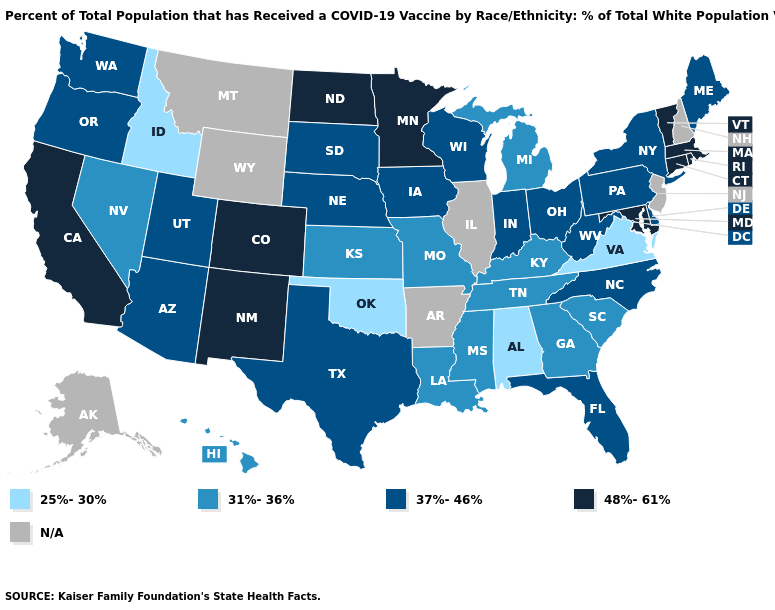What is the value of Minnesota?
Quick response, please. 48%-61%. Is the legend a continuous bar?
Answer briefly. No. Does Arizona have the highest value in the West?
Keep it brief. No. What is the value of Washington?
Write a very short answer. 37%-46%. Among the states that border Alabama , which have the highest value?
Keep it brief. Florida. What is the highest value in states that border South Dakota?
Quick response, please. 48%-61%. What is the highest value in the MidWest ?
Write a very short answer. 48%-61%. Which states hav the highest value in the South?
Quick response, please. Maryland. Does Virginia have the lowest value in the South?
Quick response, please. Yes. Name the states that have a value in the range N/A?
Give a very brief answer. Alaska, Arkansas, Illinois, Montana, New Hampshire, New Jersey, Wyoming. What is the highest value in states that border Colorado?
Write a very short answer. 48%-61%. What is the highest value in the USA?
Give a very brief answer. 48%-61%. Which states hav the highest value in the West?
Give a very brief answer. California, Colorado, New Mexico. Which states have the highest value in the USA?
Keep it brief. California, Colorado, Connecticut, Maryland, Massachusetts, Minnesota, New Mexico, North Dakota, Rhode Island, Vermont. What is the highest value in the USA?
Answer briefly. 48%-61%. 